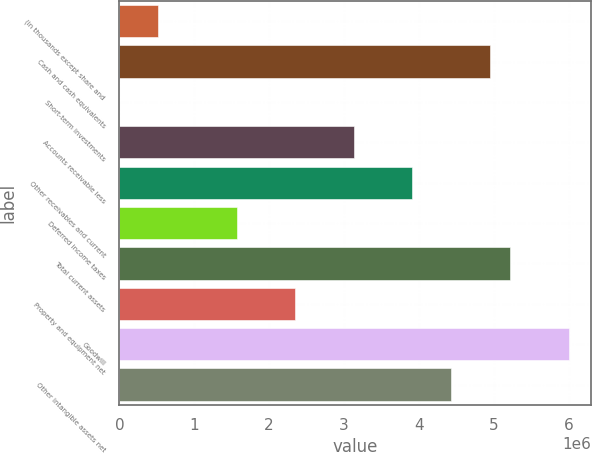Convert chart. <chart><loc_0><loc_0><loc_500><loc_500><bar_chart><fcel>(in thousands except share and<fcel>Cash and cash equivalents<fcel>Short-term investments<fcel>Accounts receivable less<fcel>Other receivables and current<fcel>Deferred income taxes<fcel>Total current assets<fcel>Property and equipment net<fcel>Goodwill<fcel>Other intangible assets net<nl><fcel>521845<fcel>4.95369e+06<fcel>452<fcel>3.12881e+06<fcel>3.9109e+06<fcel>1.56463e+06<fcel>5.21438e+06<fcel>2.34672e+06<fcel>5.99647e+06<fcel>4.43229e+06<nl></chart> 